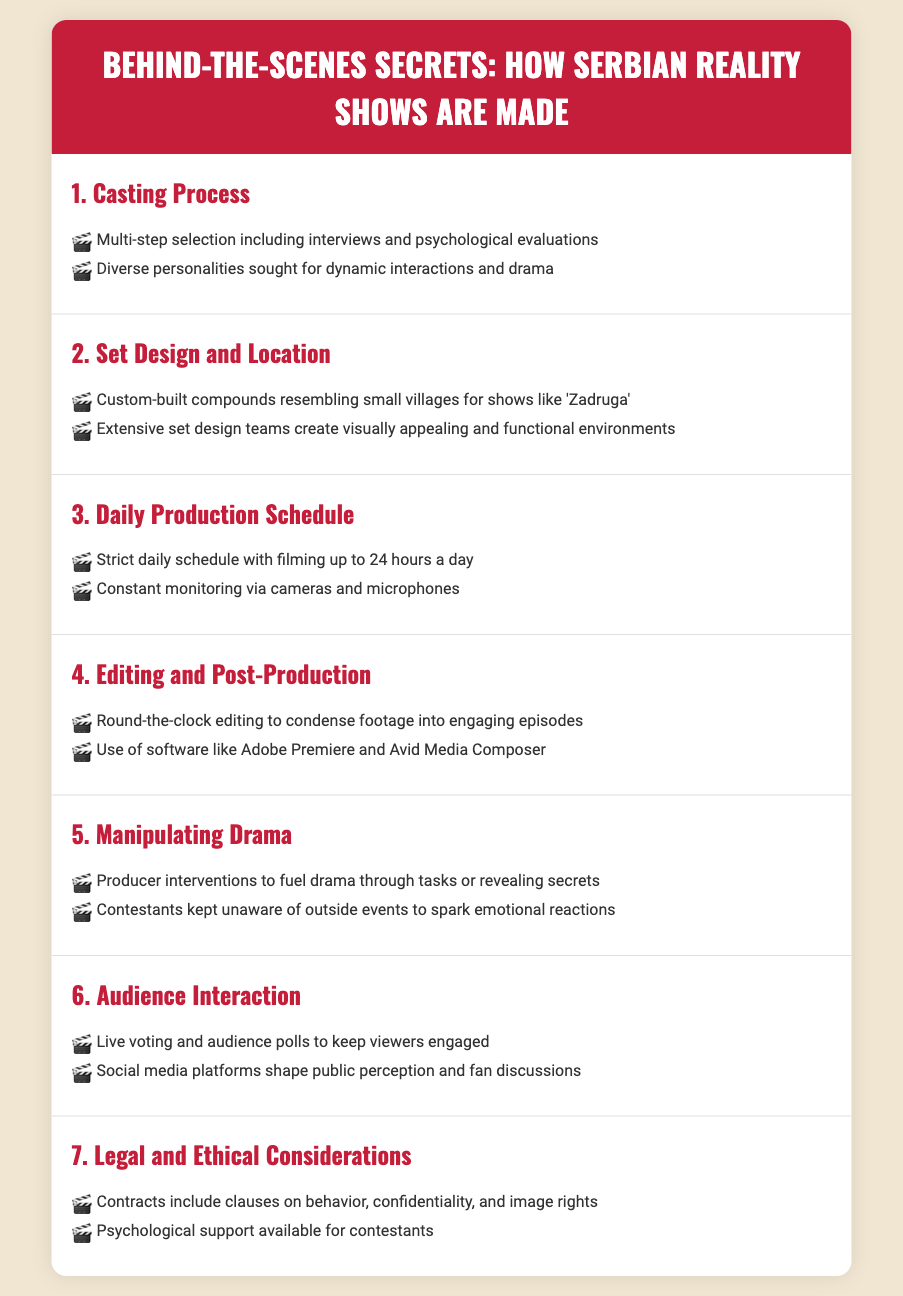What is the primary focus of the casting process? The casting process focuses on a multi-step selection including interviews and psychological evaluations.
Answer: Multi-step selection What is a key feature of the set design for shows like 'Zadruga'? The set design includes custom-built compounds resembling small villages.
Answer: Custom-built compounds How many hours a day is filming conducted? The filming is conducted up to 24 hours a day according to the daily production schedule.
Answer: 24 hours What software is used in the editing and post-production phase? Two software mentioned are Adobe Premiere and Avid Media Composer used for editing.
Answer: Adobe Premiere and Avid Media Composer How do producers manipulate drama in reality shows? Producers manipulate drama by intervening with tasks or revealing secrets to contestants.
Answer: Producer interventions What is one method used for audience interaction? Live voting is one method employed for audience interaction to keep viewers engaged.
Answer: Live voting What do contracts for contestants include? The contracts include clauses on behavior, confidentiality, and image rights.
Answer: Behavior, confidentiality, and image rights What kind of support is available for contestants? Psychological support is made available for contestants during the show.
Answer: Psychological support 